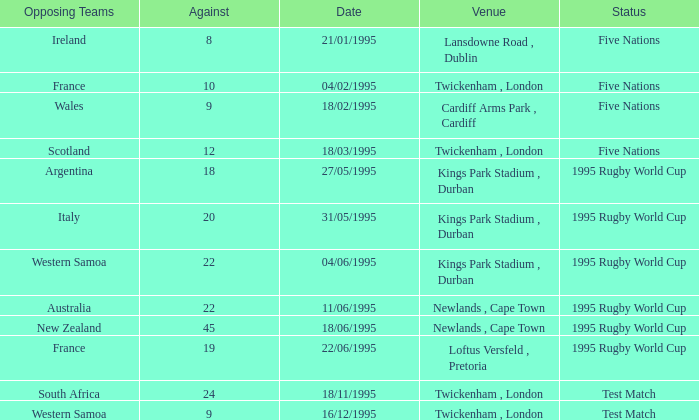On which date did a 1995 rugby world cup match take place with a score of 20 against the opposing team? 31/05/1995. 